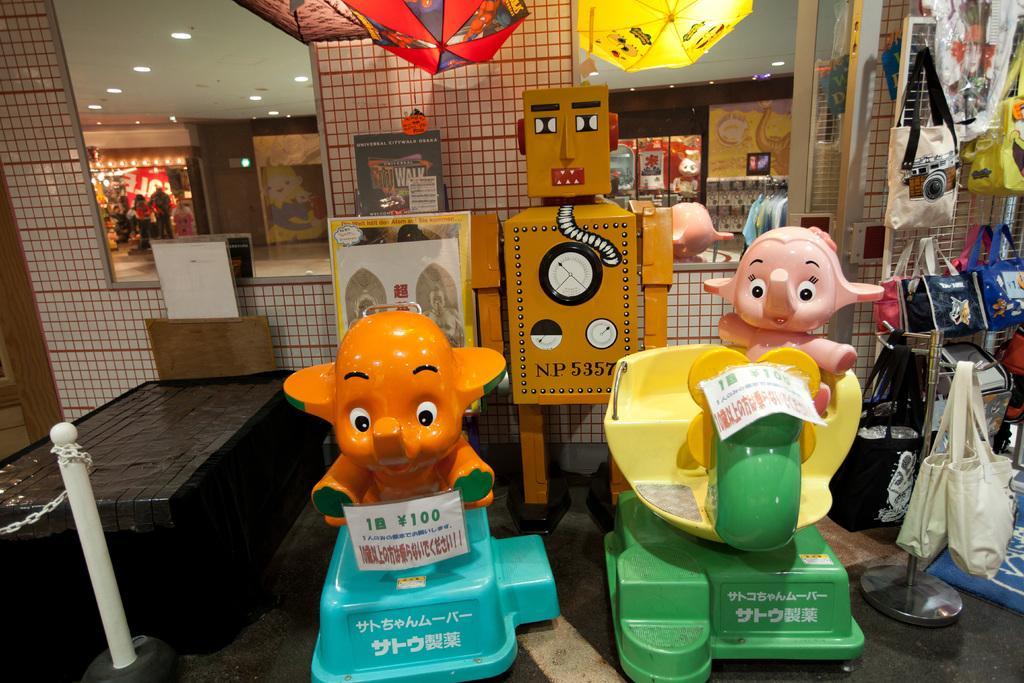How would you summarize this image in a sentence or two? In this image I can see these are the two elephant toys. on the right side there are handbags, at the back side there are mirrors in this image. 